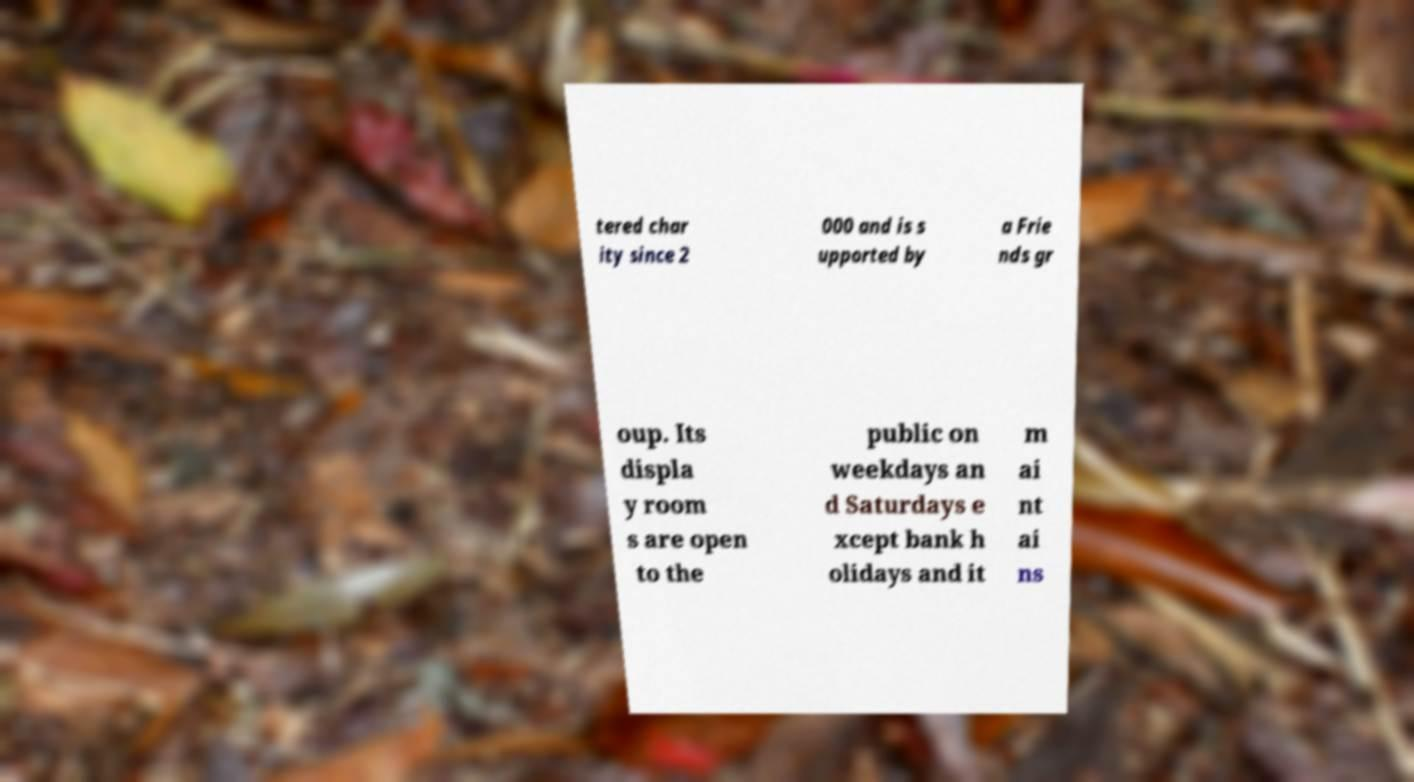Can you accurately transcribe the text from the provided image for me? tered char ity since 2 000 and is s upported by a Frie nds gr oup. Its displa y room s are open to the public on weekdays an d Saturdays e xcept bank h olidays and it m ai nt ai ns 